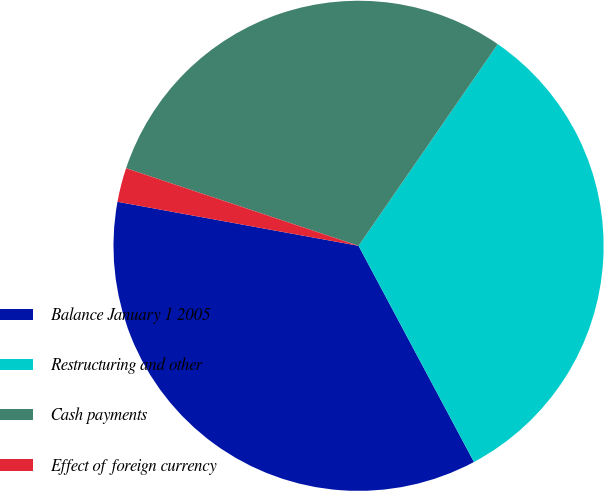Convert chart to OTSL. <chart><loc_0><loc_0><loc_500><loc_500><pie_chart><fcel>Balance January 1 2005<fcel>Restructuring and other<fcel>Cash payments<fcel>Effect of foreign currency<nl><fcel>35.68%<fcel>32.58%<fcel>29.49%<fcel>2.25%<nl></chart> 